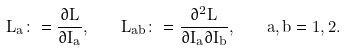Convert formula to latex. <formula><loc_0><loc_0><loc_500><loc_500>L _ { a } \colon = { \frac { \partial L } { \partial I _ { a } } } , \quad L _ { a b } \colon = { \frac { \partial ^ { 2 } L } { \partial I _ { a } \partial I _ { b } } } , \quad a , b = 1 , 2 .</formula> 